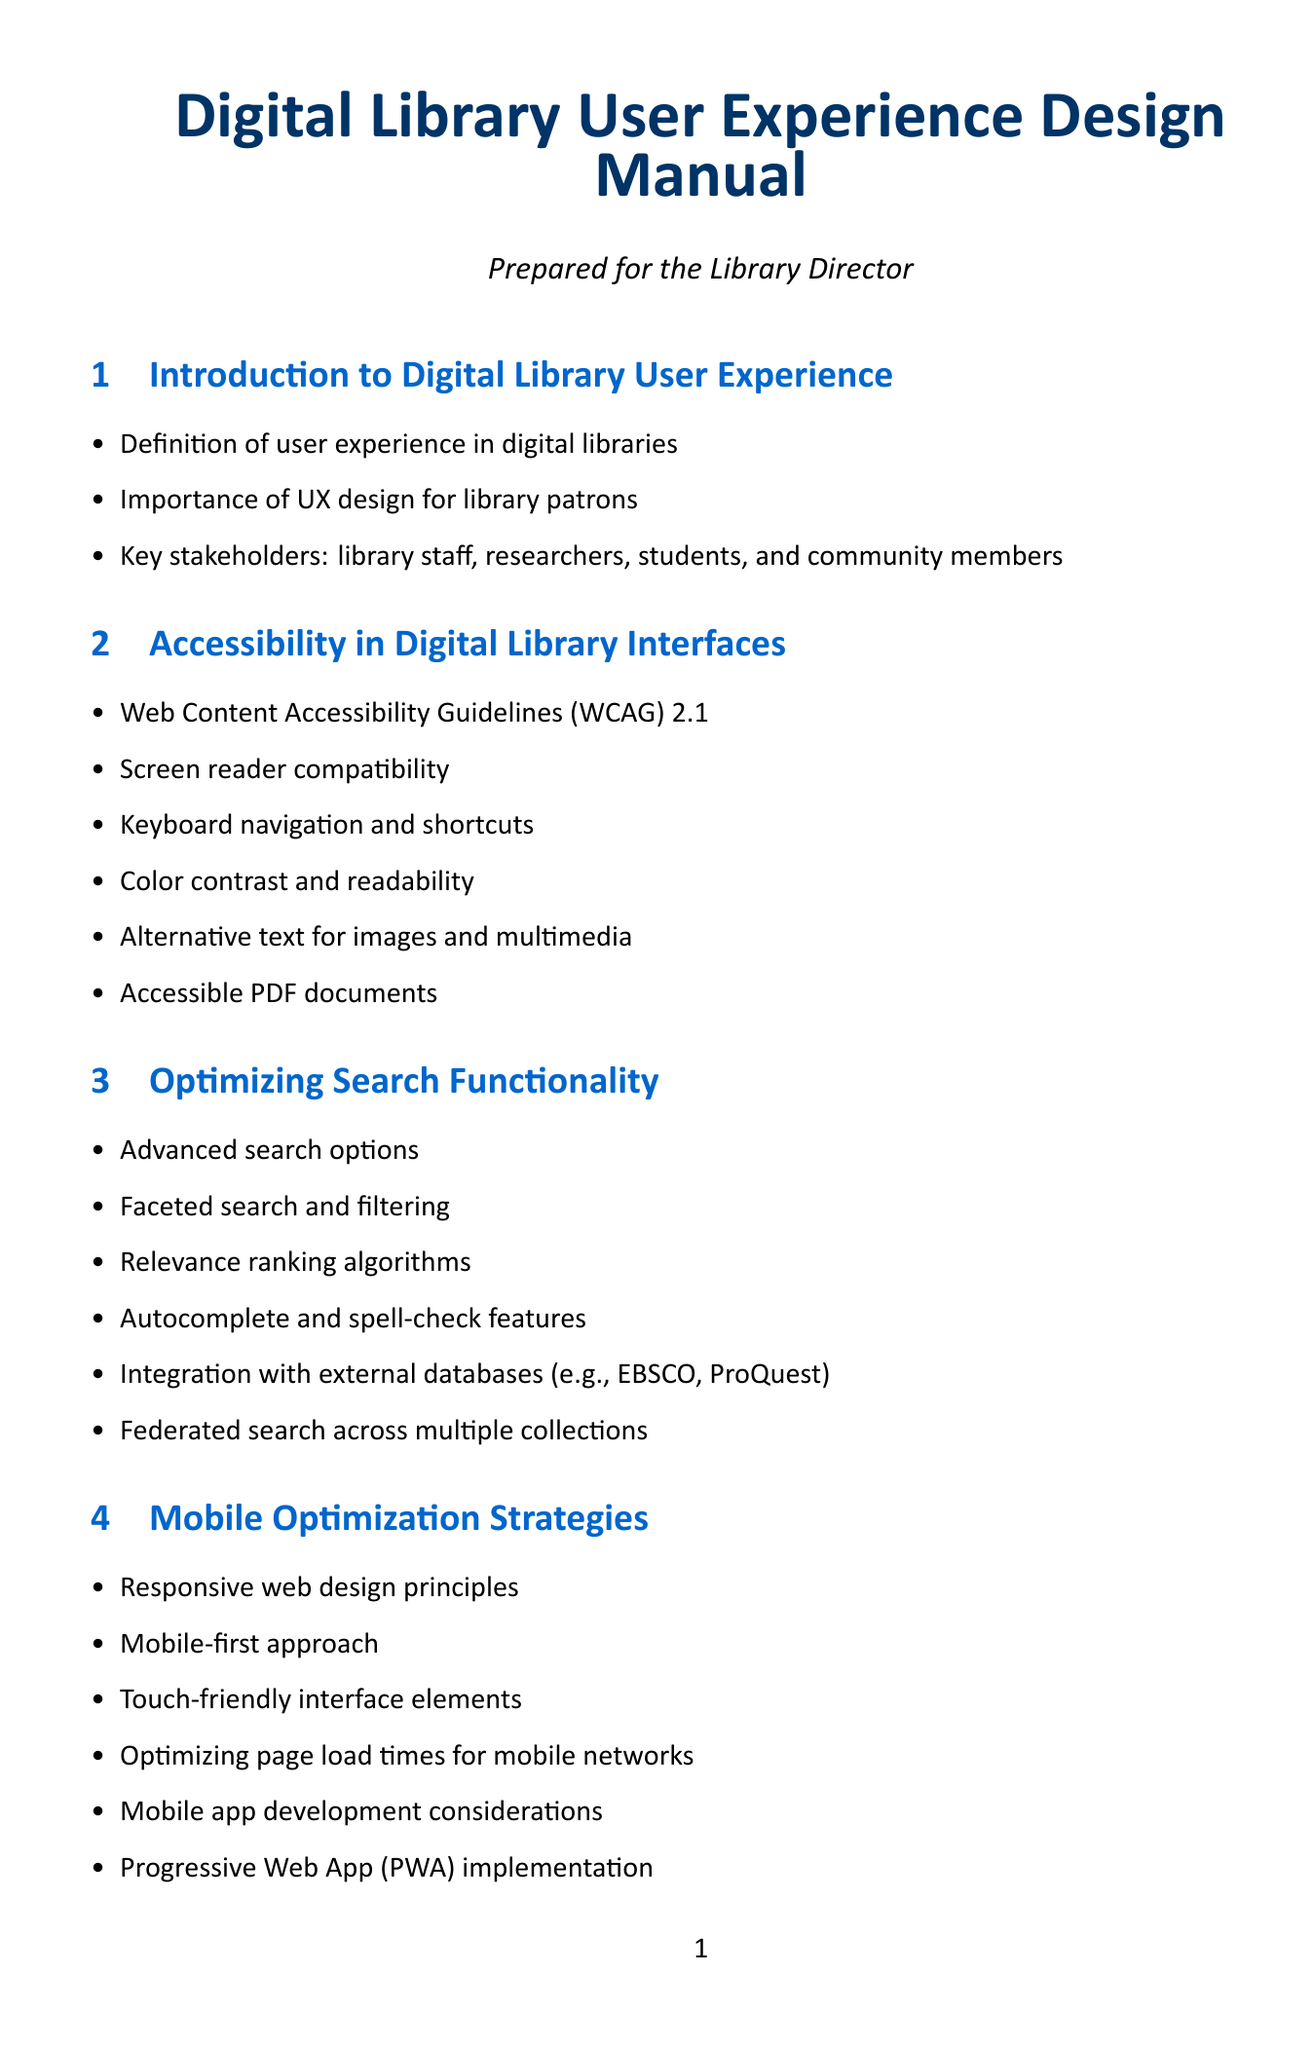What are the Web Content Accessibility Guidelines version? The document specifies the guidelines for accessibility in digital library interfaces as WCAG 2.1.
Answer: WCAG 2.1 What is one feature of optimizing search functionality? The document mentions several features of optimizing search such as autocomplete and spell-check features.
Answer: Autocomplete Which section covers mobile optimization strategies? The document includes a section specifically dedicated to mobile optimization, titled "Mobile Optimization Strategies."
Answer: Mobile Optimization Strategies How many popular digital library platforms are listed? The document lists a total of six popular digital library platforms.
Answer: Six What principle is emphasized in the mobile-first approach? The document indicates that the mobile-first approach is part of the mobile optimization strategies.
Answer: Mobile-first approach What aspect of user experience is defined in the first section? The introductory section of the document provides a definition of user experience in digital libraries.
Answer: Definition of user experience What is a common method for user testing? The document outlines usability testing methods as part of the user-centered design process.
Answer: Usability testing methods What technology is mentioned regarding future trends in digital library UX? The document refers to Artificial Intelligence and Machine Learning integration as a future trend.
Answer: Artificial Intelligence and Machine Learning integration What does WCAG stand for? The document discusses the Web Content Accessibility Guidelines, which are referred to as WCAG.
Answer: Web Content Accessibility Guidelines 